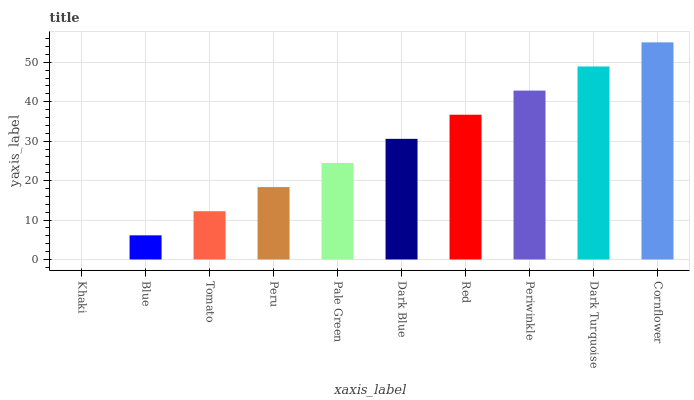Is Khaki the minimum?
Answer yes or no. Yes. Is Cornflower the maximum?
Answer yes or no. Yes. Is Blue the minimum?
Answer yes or no. No. Is Blue the maximum?
Answer yes or no. No. Is Blue greater than Khaki?
Answer yes or no. Yes. Is Khaki less than Blue?
Answer yes or no. Yes. Is Khaki greater than Blue?
Answer yes or no. No. Is Blue less than Khaki?
Answer yes or no. No. Is Dark Blue the high median?
Answer yes or no. Yes. Is Pale Green the low median?
Answer yes or no. Yes. Is Peru the high median?
Answer yes or no. No. Is Dark Turquoise the low median?
Answer yes or no. No. 